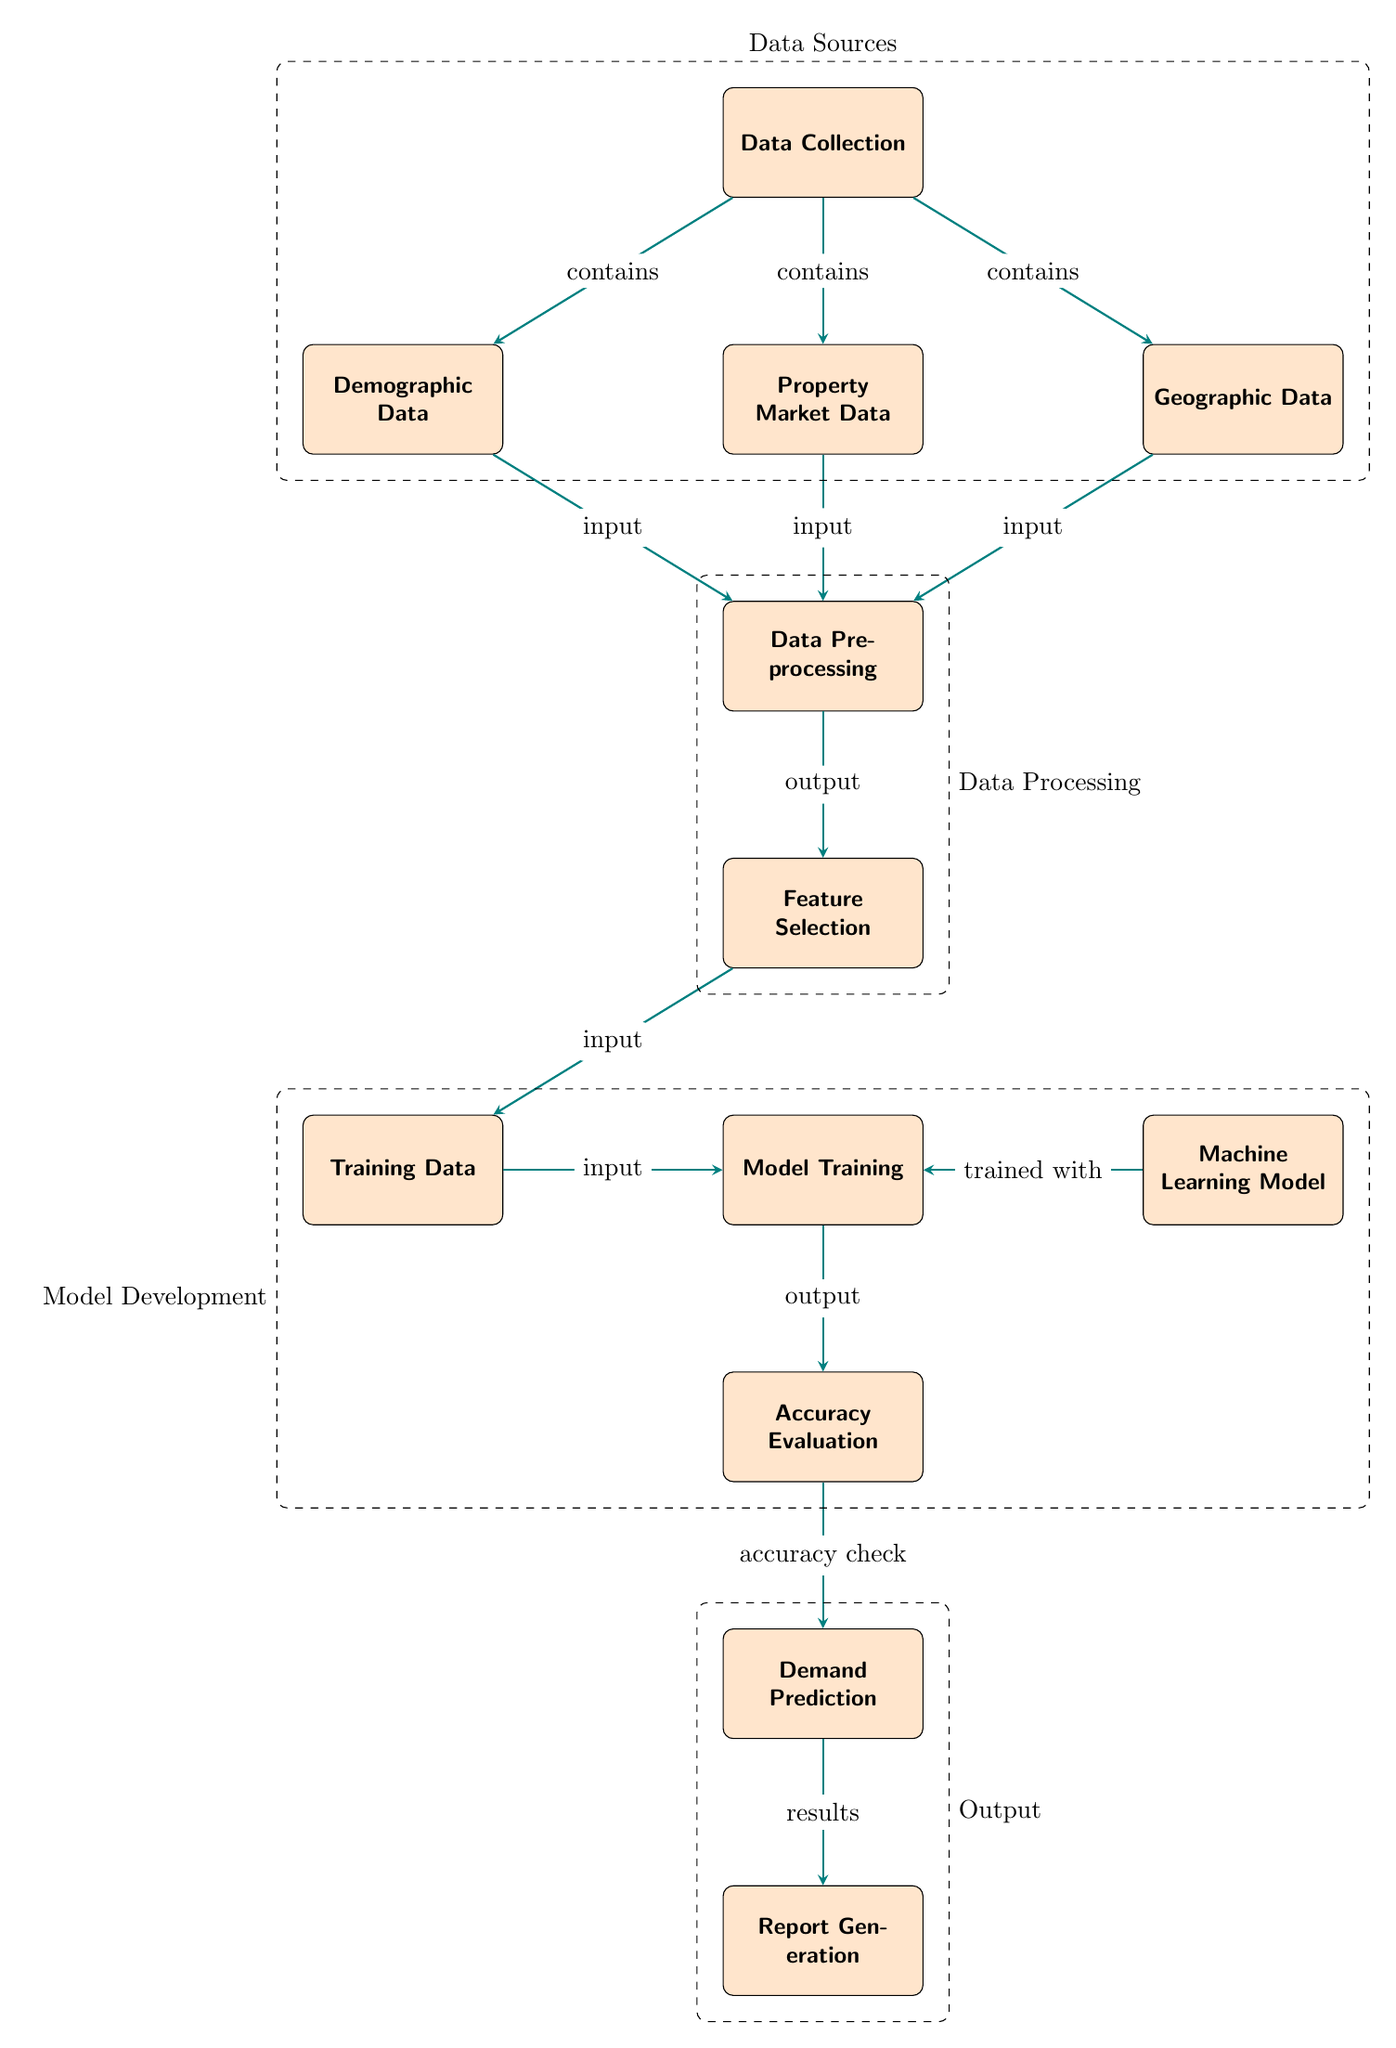What is the first step in the diagram? The first step in the diagram is "Data Collection," which is the top node that initiates the entire process.
Answer: Data Collection How many data sources are identified in the diagram? The diagram identifies three data sources: "Demographic Data," "Property Market Data," and "Geographic Data," which are shown as input nodes connected to "Data Collection."
Answer: Three What type of model is mentioned in the diagram? The diagram mentions a "Machine Learning Model," which is a specific step within the model development phase.
Answer: Machine Learning Model What is the result of "Model Training"? The output of "Model Training" is "Accuracy Evaluation," which is the next step after model training in the flow.
Answer: Accuracy Evaluation Which component comes before "Demand Prediction"? The component that comes before "Demand Prediction" is "Accuracy Evaluation," indicating that the prediction follows the evaluation stage.
Answer: Accuracy Evaluation What is the last step in the diagram? The last step in the diagram is "Report Generation," which summarizes the results of the demand predictions.
Answer: Report Generation What connects "Feature Selection" and "Training Data"? The connection between "Feature Selection" and "Training Data" is the arrow labeled "input," indicating that the selected features are used as input for training data.
Answer: Input How does "Machine Learning Model" contribute to the process? The "Machine Learning Model" is trained with the "Training Data," allowing it to learn patterns and make predictions during the process.
Answer: Trained with What follows after "Data Preprocessing"? The step following "Data Preprocessing" is "Feature Selection," which indicates that data needs to be appropriately selected after preprocessing is done.
Answer: Feature Selection 